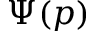Convert formula to latex. <formula><loc_0><loc_0><loc_500><loc_500>\Psi ( p )</formula> 